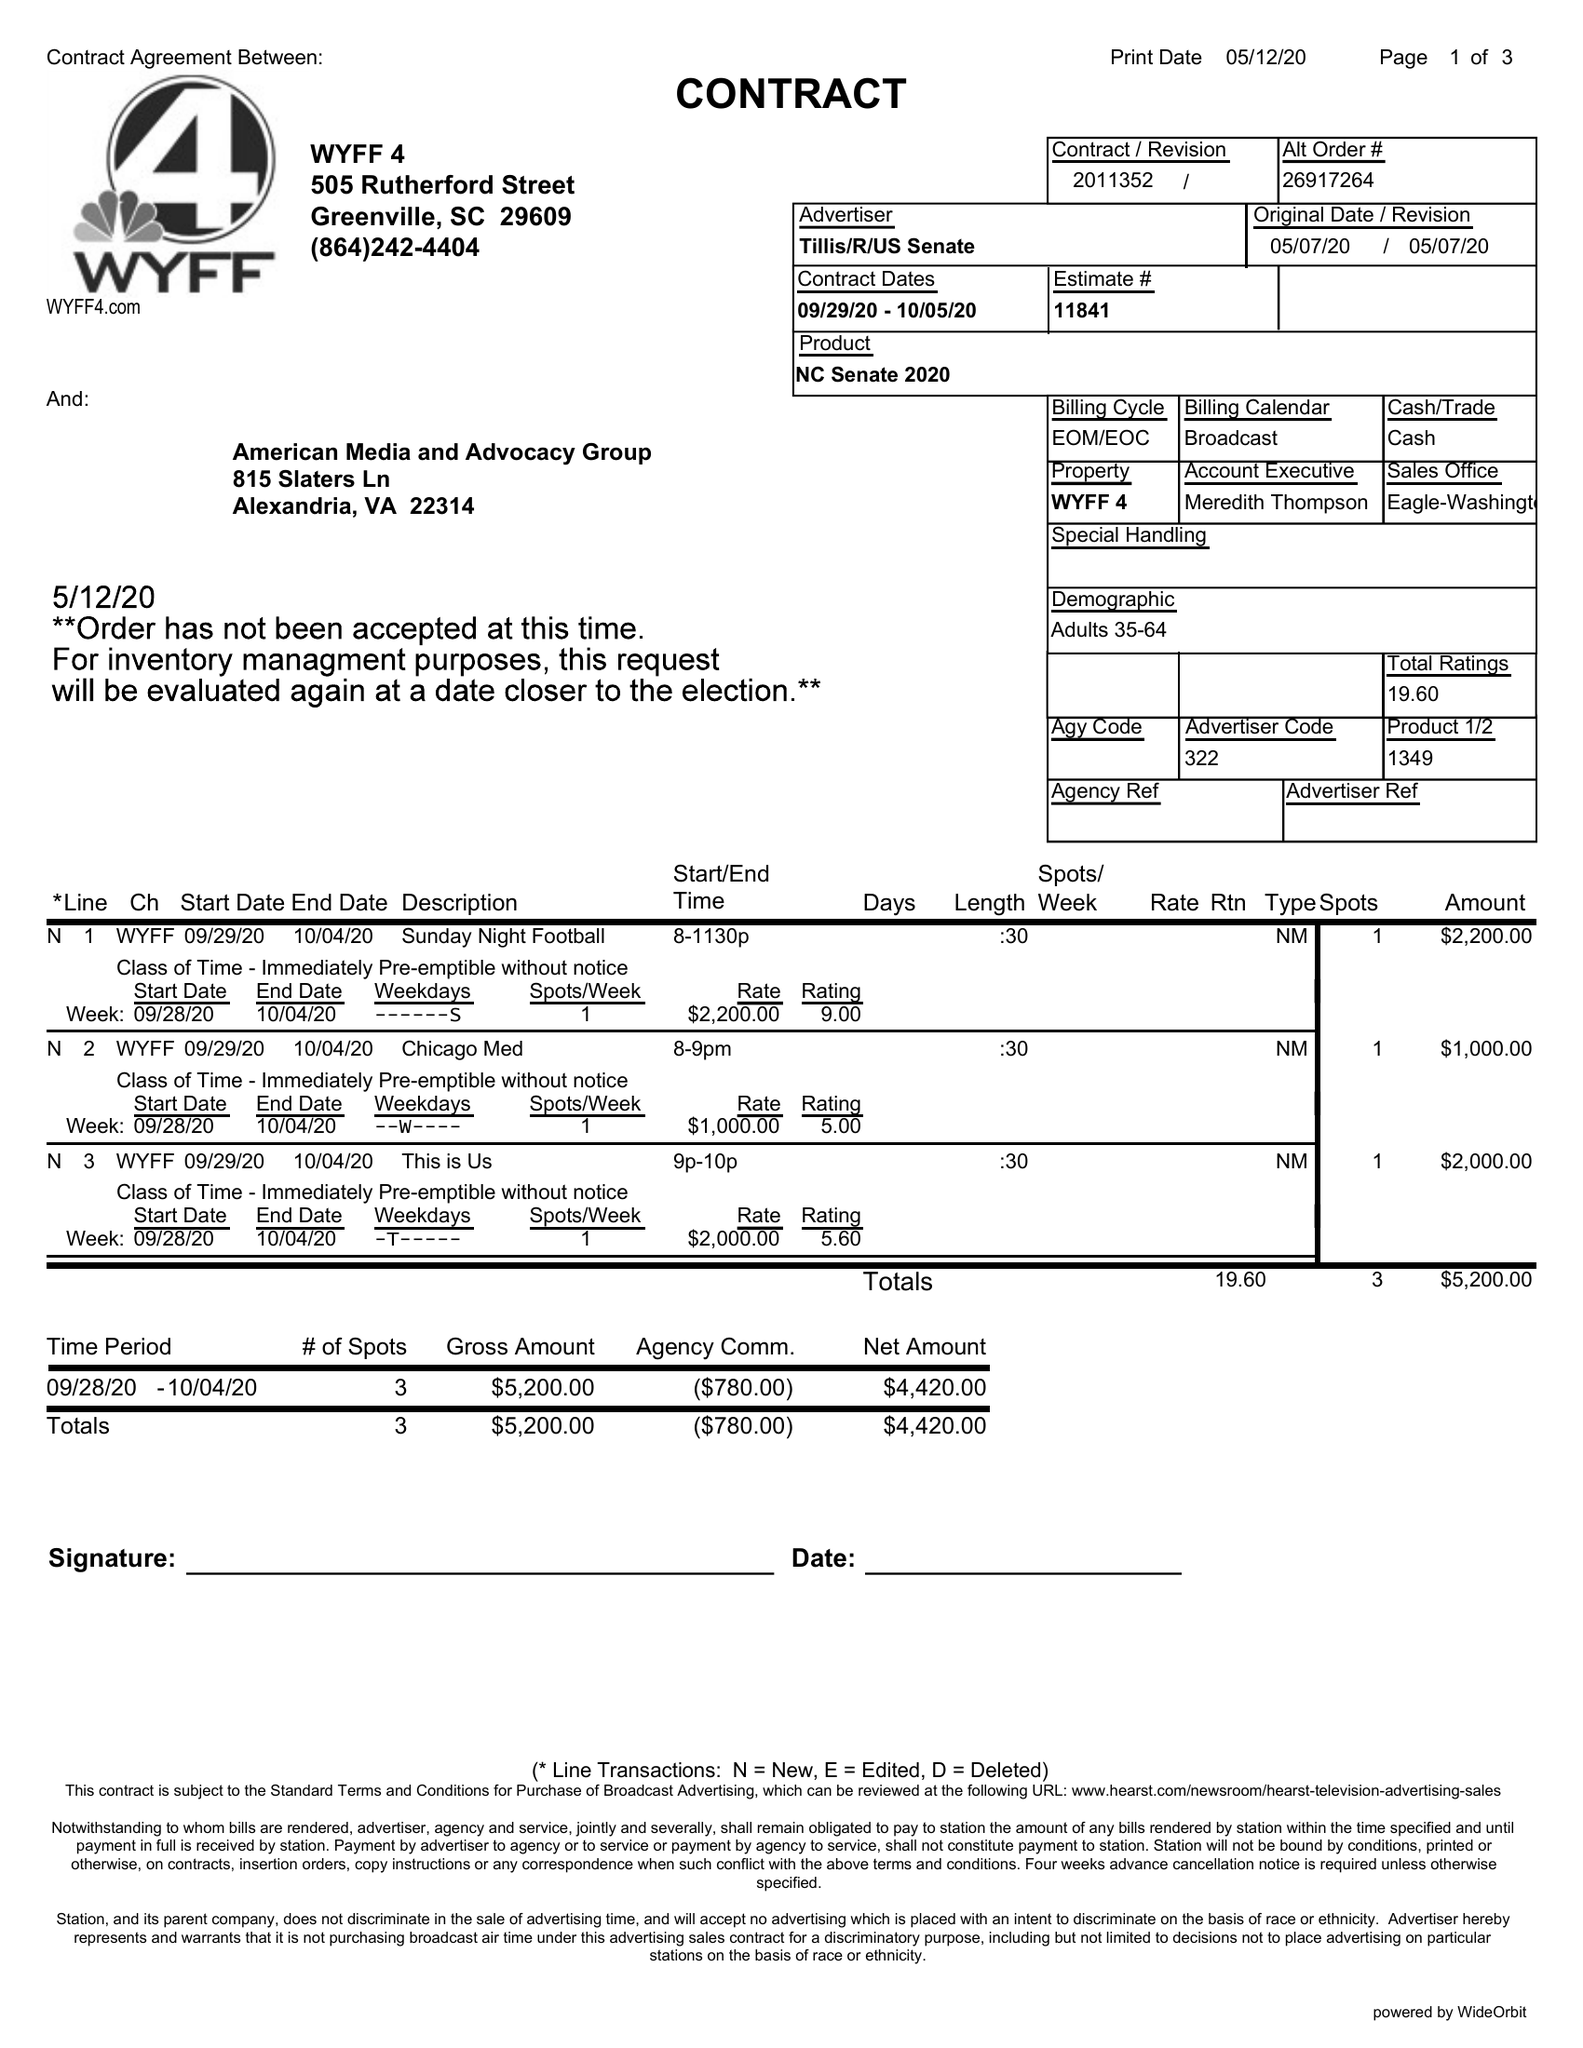What is the value for the flight_to?
Answer the question using a single word or phrase. 10/05/20 